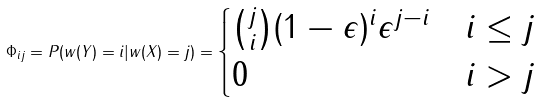<formula> <loc_0><loc_0><loc_500><loc_500>\Phi _ { i j } = P ( w ( Y ) = i | w ( X ) = j ) = \begin{cases} \binom { j } { i } ( 1 - \epsilon ) ^ { i } \epsilon ^ { j - i } & i \leq j \\ 0 & i > j \\ \end{cases}</formula> 